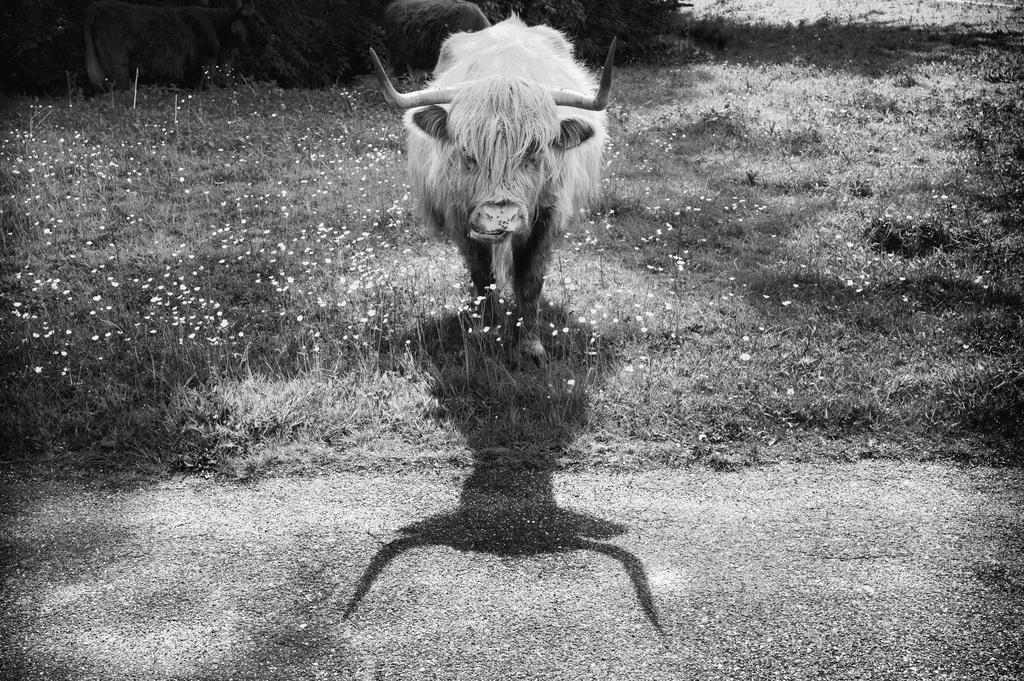What is the color scheme of the image? The image is black and white. What can be seen on the ground in the image? There is an animal on the ground in the image. What type of vegetation is present in the image? There is grass with flowers in the image. What else can be seen in the background of the image? There are trees visible in the image. What type of shoes is the animal wearing in the image? There are no shoes present in the image, as the animal is on the ground and not wearing any footwear. 